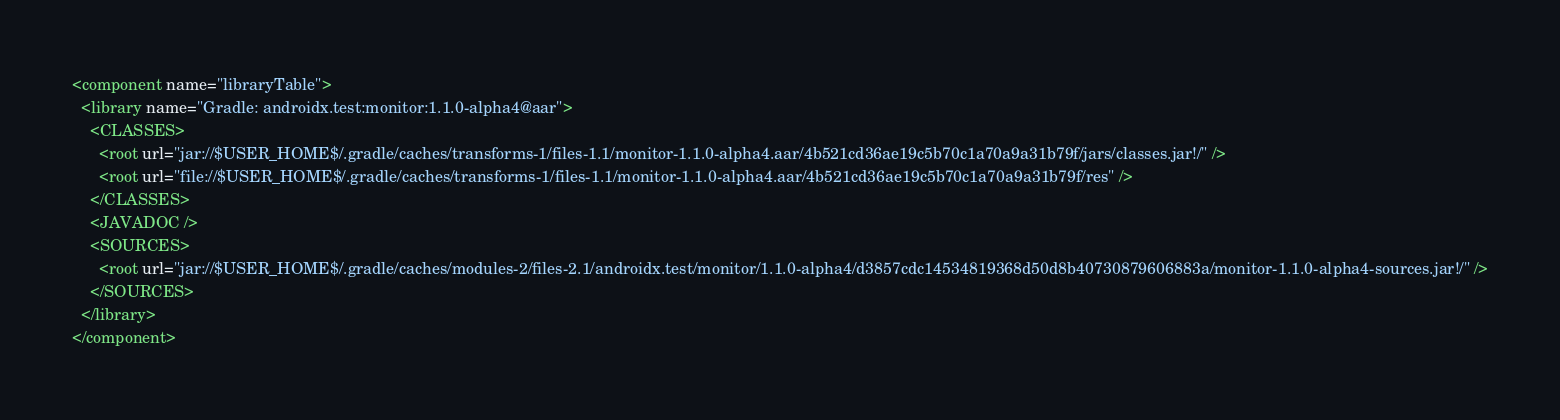<code> <loc_0><loc_0><loc_500><loc_500><_XML_><component name="libraryTable">
  <library name="Gradle: androidx.test:monitor:1.1.0-alpha4@aar">
    <CLASSES>
      <root url="jar://$USER_HOME$/.gradle/caches/transforms-1/files-1.1/monitor-1.1.0-alpha4.aar/4b521cd36ae19c5b70c1a70a9a31b79f/jars/classes.jar!/" />
      <root url="file://$USER_HOME$/.gradle/caches/transforms-1/files-1.1/monitor-1.1.0-alpha4.aar/4b521cd36ae19c5b70c1a70a9a31b79f/res" />
    </CLASSES>
    <JAVADOC />
    <SOURCES>
      <root url="jar://$USER_HOME$/.gradle/caches/modules-2/files-2.1/androidx.test/monitor/1.1.0-alpha4/d3857cdc14534819368d50d8b40730879606883a/monitor-1.1.0-alpha4-sources.jar!/" />
    </SOURCES>
  </library>
</component></code> 